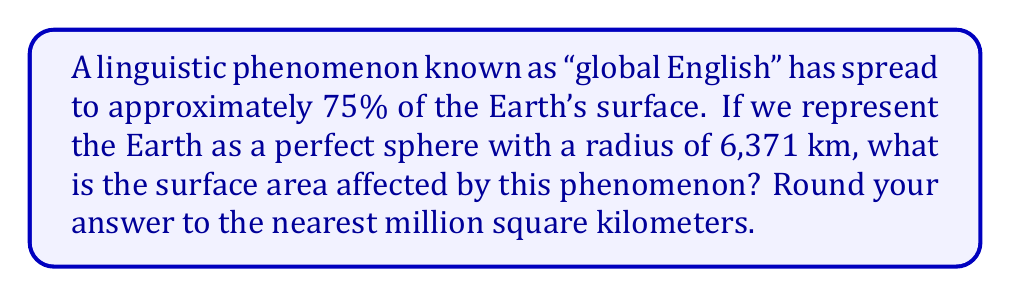Solve this math problem. To solve this problem, we'll follow these steps:

1) The formula for the surface area of a sphere is:
   $$A = 4\pi r^2$$
   where $A$ is the surface area and $r$ is the radius.

2) We're given that the radius of the Earth is 6,371 km. Let's substitute this into our formula:
   $$A = 4\pi (6,371)^2$$

3) Let's calculate this:
   $$A = 4 \times 3.14159... \times 6,371^2$$
   $$A = 4 \times 3.14159... \times 40,589,641$$
   $$A \approx 510,064,471.9 \text{ km}^2$$

4) This is the total surface area of the Earth. However, the question asks for 75% of this area:
   $$0.75 \times 510,064,471.9 = 382,548,353.9 \text{ km}^2$$

5) Rounding to the nearest million square kilometers:
   $$382,548,353.9 \text{ km}^2 \approx 383,000,000 \text{ km}^2$$

Thus, the surface area affected by the "global English" phenomenon is approximately 383 million square kilometers.
Answer: 383,000,000 km² 